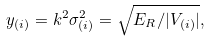Convert formula to latex. <formula><loc_0><loc_0><loc_500><loc_500>y _ { ( i ) } = k ^ { 2 } \sigma _ { ( i ) } ^ { 2 } = \sqrt { E _ { R } / | V _ { ( i ) } | } ,</formula> 